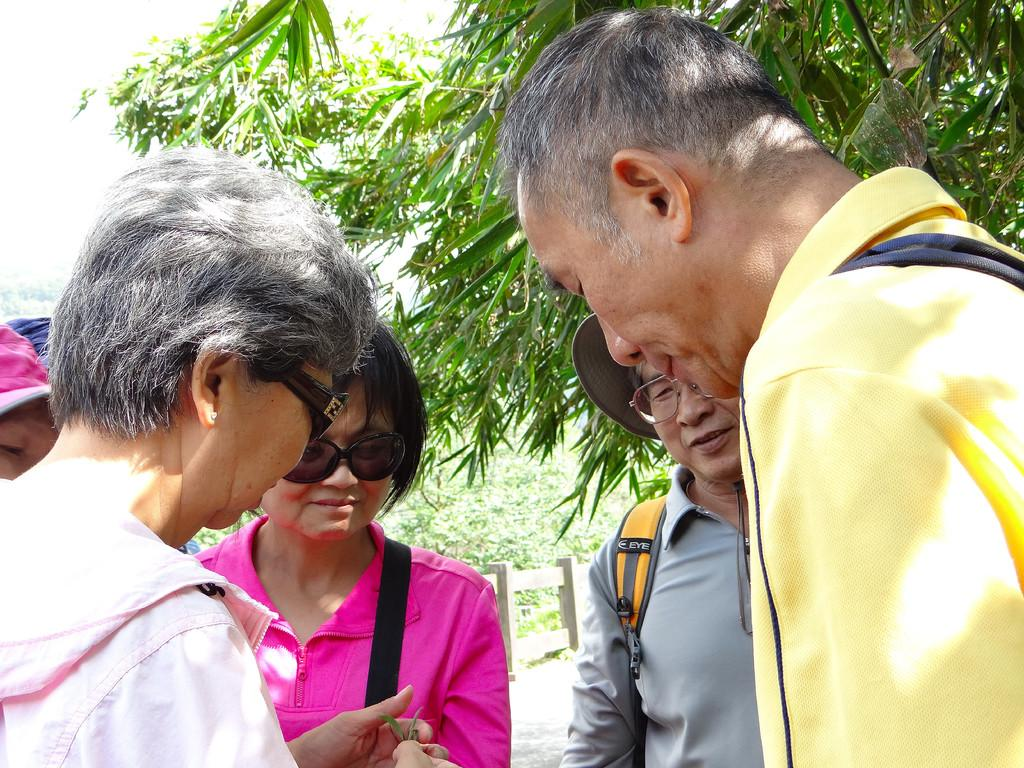What are the people in the image doing? The people in the image are standing on the road. What is located behind the people? There is a fence behind the people. What can be seen in the distance in the image? There are trees and the sky visible in the background of the image. What type of wave can be seen crashing on the shore in the image? There is no shore or wave present in the image; it features people standing on a road with a fence and trees in the background. How many girls are visible in the image? The provided facts do not mention the gender of the people in the image, so it cannot be determined from the image. 